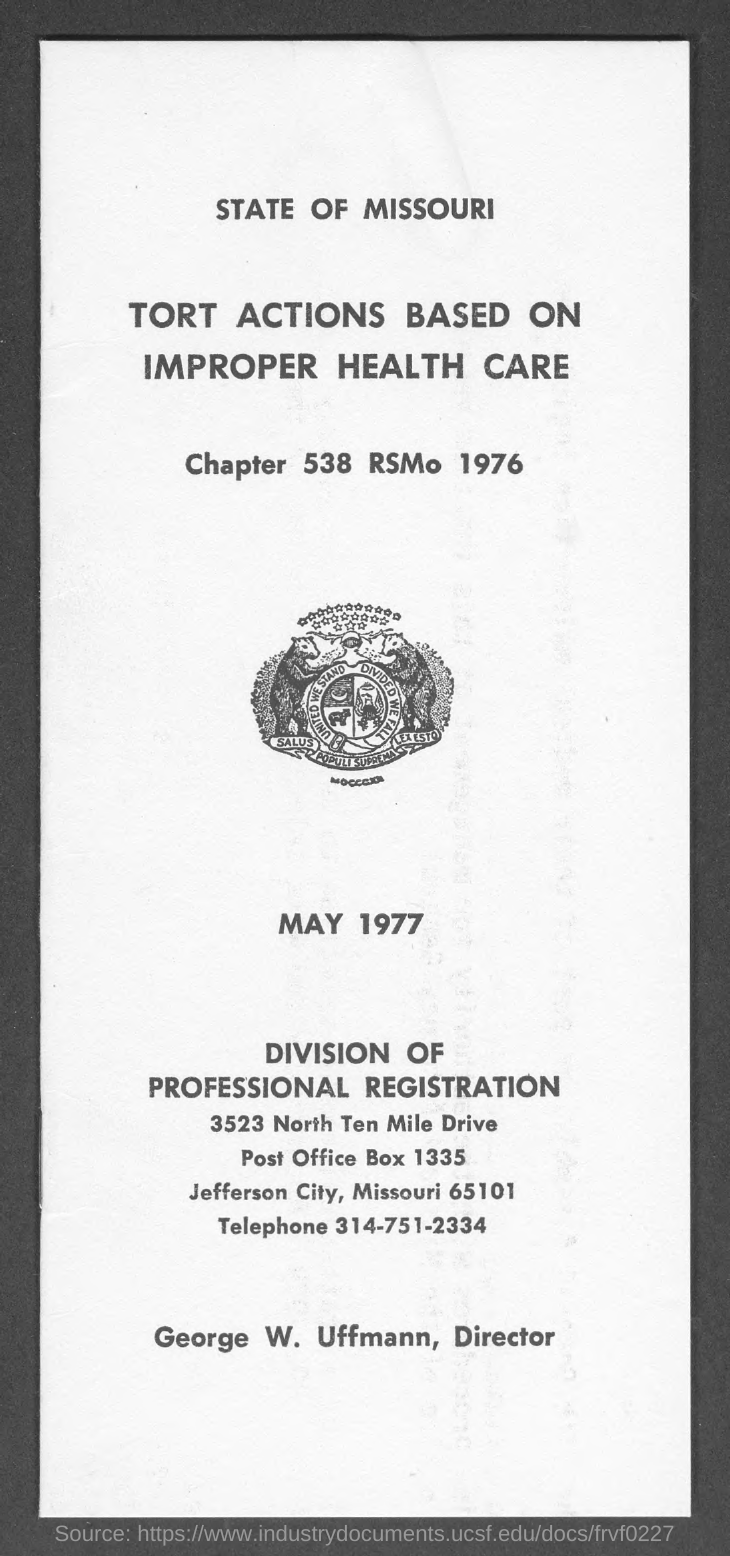Indicate a few pertinent items in this graphic. The RSMo number mentioned in the given page is 1976. The date mentioned in the given page is May 1977. The director mentioned in the given page is George W. Uffmann. The chapter number mentioned on page 538 is...". The post office box number mentioned on the given page is 1335. 